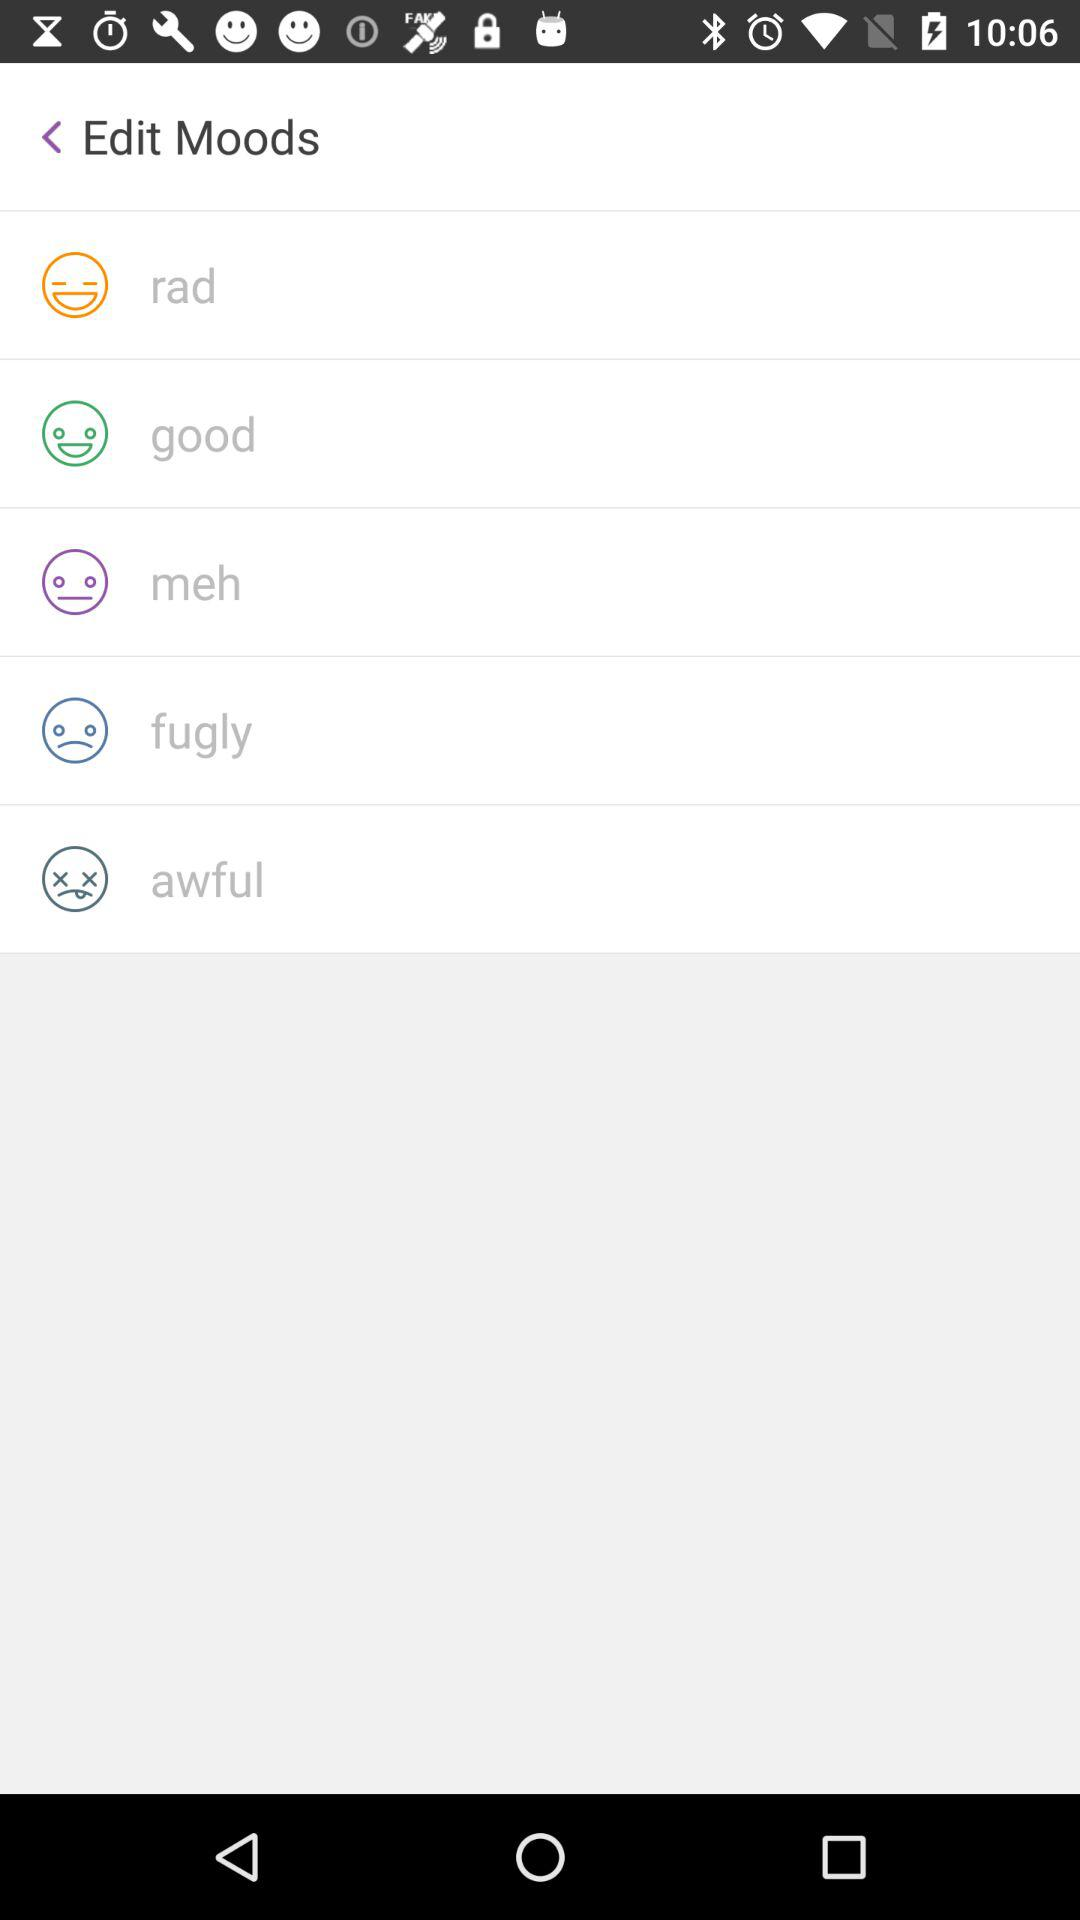How many moods are shown with a sad face?
Answer the question using a single word or phrase. 2 